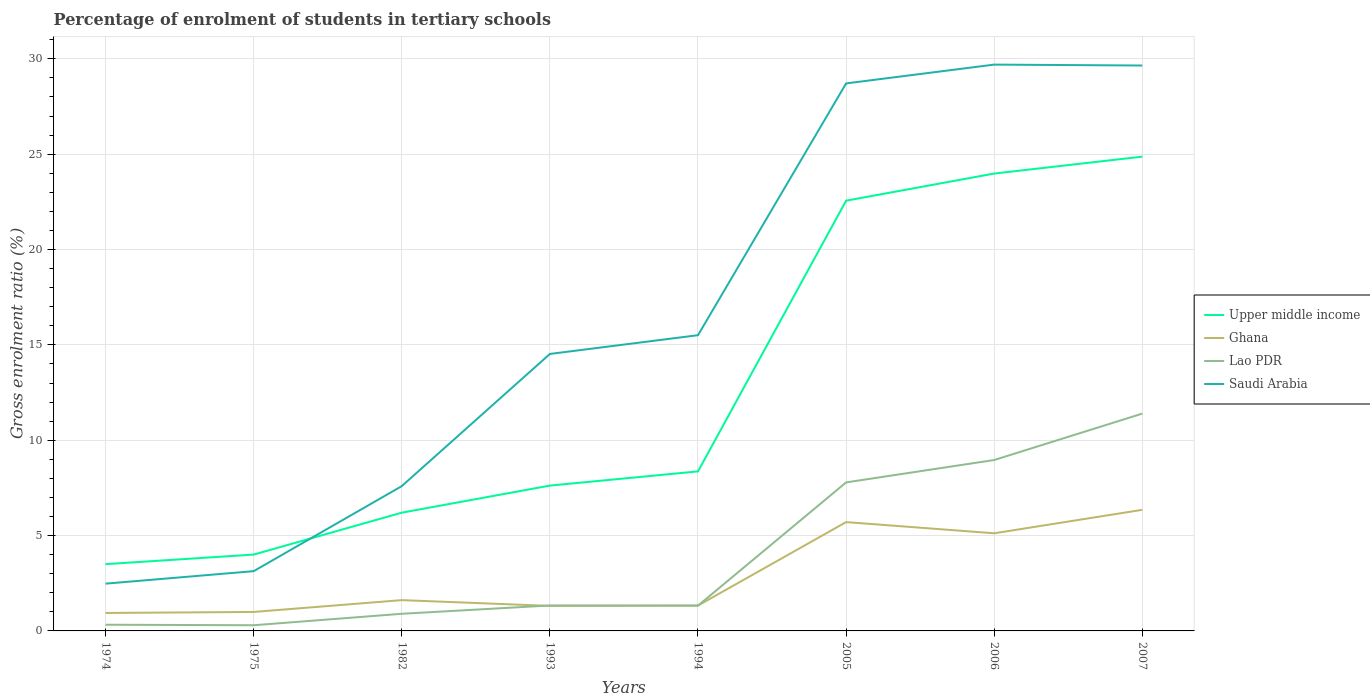How many different coloured lines are there?
Ensure brevity in your answer.  4. Across all years, what is the maximum percentage of students enrolled in tertiary schools in Lao PDR?
Give a very brief answer. 0.3. In which year was the percentage of students enrolled in tertiary schools in Saudi Arabia maximum?
Offer a terse response. 1974. What is the total percentage of students enrolled in tertiary schools in Saudi Arabia in the graph?
Give a very brief answer. -26.56. What is the difference between the highest and the second highest percentage of students enrolled in tertiary schools in Lao PDR?
Your answer should be compact. 11.1. What is the difference between the highest and the lowest percentage of students enrolled in tertiary schools in Ghana?
Your answer should be compact. 3. Does the graph contain any zero values?
Your answer should be compact. No. How are the legend labels stacked?
Offer a terse response. Vertical. What is the title of the graph?
Your answer should be very brief. Percentage of enrolment of students in tertiary schools. What is the label or title of the Y-axis?
Your answer should be compact. Gross enrolment ratio (%). What is the Gross enrolment ratio (%) of Upper middle income in 1974?
Offer a very short reply. 3.5. What is the Gross enrolment ratio (%) of Lao PDR in 1974?
Your answer should be compact. 0.32. What is the Gross enrolment ratio (%) of Saudi Arabia in 1974?
Keep it short and to the point. 2.48. What is the Gross enrolment ratio (%) of Upper middle income in 1975?
Make the answer very short. 4. What is the Gross enrolment ratio (%) of Ghana in 1975?
Offer a very short reply. 1. What is the Gross enrolment ratio (%) of Lao PDR in 1975?
Provide a short and direct response. 0.3. What is the Gross enrolment ratio (%) in Saudi Arabia in 1975?
Your response must be concise. 3.13. What is the Gross enrolment ratio (%) in Upper middle income in 1982?
Offer a terse response. 6.2. What is the Gross enrolment ratio (%) of Ghana in 1982?
Your answer should be compact. 1.62. What is the Gross enrolment ratio (%) in Lao PDR in 1982?
Make the answer very short. 0.9. What is the Gross enrolment ratio (%) of Saudi Arabia in 1982?
Offer a terse response. 7.59. What is the Gross enrolment ratio (%) of Upper middle income in 1993?
Provide a short and direct response. 7.62. What is the Gross enrolment ratio (%) in Ghana in 1993?
Your answer should be very brief. 1.31. What is the Gross enrolment ratio (%) in Lao PDR in 1993?
Make the answer very short. 1.33. What is the Gross enrolment ratio (%) in Saudi Arabia in 1993?
Offer a terse response. 14.52. What is the Gross enrolment ratio (%) in Upper middle income in 1994?
Provide a short and direct response. 8.37. What is the Gross enrolment ratio (%) of Ghana in 1994?
Your answer should be compact. 1.33. What is the Gross enrolment ratio (%) of Lao PDR in 1994?
Your answer should be compact. 1.33. What is the Gross enrolment ratio (%) of Saudi Arabia in 1994?
Provide a short and direct response. 15.51. What is the Gross enrolment ratio (%) in Upper middle income in 2005?
Keep it short and to the point. 22.56. What is the Gross enrolment ratio (%) of Ghana in 2005?
Your response must be concise. 5.71. What is the Gross enrolment ratio (%) in Lao PDR in 2005?
Provide a succinct answer. 7.79. What is the Gross enrolment ratio (%) of Saudi Arabia in 2005?
Provide a short and direct response. 28.71. What is the Gross enrolment ratio (%) of Upper middle income in 2006?
Keep it short and to the point. 23.99. What is the Gross enrolment ratio (%) in Ghana in 2006?
Your answer should be very brief. 5.12. What is the Gross enrolment ratio (%) of Lao PDR in 2006?
Ensure brevity in your answer.  8.96. What is the Gross enrolment ratio (%) of Saudi Arabia in 2006?
Offer a very short reply. 29.7. What is the Gross enrolment ratio (%) in Upper middle income in 2007?
Your answer should be compact. 24.87. What is the Gross enrolment ratio (%) of Ghana in 2007?
Provide a succinct answer. 6.35. What is the Gross enrolment ratio (%) of Lao PDR in 2007?
Keep it short and to the point. 11.4. What is the Gross enrolment ratio (%) of Saudi Arabia in 2007?
Your answer should be very brief. 29.65. Across all years, what is the maximum Gross enrolment ratio (%) of Upper middle income?
Give a very brief answer. 24.87. Across all years, what is the maximum Gross enrolment ratio (%) of Ghana?
Your response must be concise. 6.35. Across all years, what is the maximum Gross enrolment ratio (%) in Lao PDR?
Your answer should be compact. 11.4. Across all years, what is the maximum Gross enrolment ratio (%) of Saudi Arabia?
Your answer should be compact. 29.7. Across all years, what is the minimum Gross enrolment ratio (%) of Upper middle income?
Offer a terse response. 3.5. Across all years, what is the minimum Gross enrolment ratio (%) in Lao PDR?
Give a very brief answer. 0.3. Across all years, what is the minimum Gross enrolment ratio (%) of Saudi Arabia?
Make the answer very short. 2.48. What is the total Gross enrolment ratio (%) in Upper middle income in the graph?
Your response must be concise. 101.12. What is the total Gross enrolment ratio (%) in Ghana in the graph?
Give a very brief answer. 23.37. What is the total Gross enrolment ratio (%) in Lao PDR in the graph?
Your answer should be compact. 32.33. What is the total Gross enrolment ratio (%) in Saudi Arabia in the graph?
Your response must be concise. 131.3. What is the difference between the Gross enrolment ratio (%) of Upper middle income in 1974 and that in 1975?
Give a very brief answer. -0.5. What is the difference between the Gross enrolment ratio (%) of Ghana in 1974 and that in 1975?
Provide a succinct answer. -0.05. What is the difference between the Gross enrolment ratio (%) in Lao PDR in 1974 and that in 1975?
Ensure brevity in your answer.  0.03. What is the difference between the Gross enrolment ratio (%) in Saudi Arabia in 1974 and that in 1975?
Give a very brief answer. -0.66. What is the difference between the Gross enrolment ratio (%) in Upper middle income in 1974 and that in 1982?
Your answer should be very brief. -2.7. What is the difference between the Gross enrolment ratio (%) in Ghana in 1974 and that in 1982?
Provide a succinct answer. -0.67. What is the difference between the Gross enrolment ratio (%) of Lao PDR in 1974 and that in 1982?
Give a very brief answer. -0.57. What is the difference between the Gross enrolment ratio (%) in Saudi Arabia in 1974 and that in 1982?
Provide a short and direct response. -5.12. What is the difference between the Gross enrolment ratio (%) in Upper middle income in 1974 and that in 1993?
Keep it short and to the point. -4.12. What is the difference between the Gross enrolment ratio (%) of Ghana in 1974 and that in 1993?
Your answer should be compact. -0.37. What is the difference between the Gross enrolment ratio (%) in Lao PDR in 1974 and that in 1993?
Offer a very short reply. -1.01. What is the difference between the Gross enrolment ratio (%) of Saudi Arabia in 1974 and that in 1993?
Your answer should be very brief. -12.05. What is the difference between the Gross enrolment ratio (%) in Upper middle income in 1974 and that in 1994?
Provide a succinct answer. -4.87. What is the difference between the Gross enrolment ratio (%) of Ghana in 1974 and that in 1994?
Provide a short and direct response. -0.39. What is the difference between the Gross enrolment ratio (%) of Lao PDR in 1974 and that in 1994?
Provide a short and direct response. -1. What is the difference between the Gross enrolment ratio (%) of Saudi Arabia in 1974 and that in 1994?
Your answer should be very brief. -13.03. What is the difference between the Gross enrolment ratio (%) of Upper middle income in 1974 and that in 2005?
Provide a short and direct response. -19.06. What is the difference between the Gross enrolment ratio (%) of Ghana in 1974 and that in 2005?
Ensure brevity in your answer.  -4.77. What is the difference between the Gross enrolment ratio (%) of Lao PDR in 1974 and that in 2005?
Provide a short and direct response. -7.46. What is the difference between the Gross enrolment ratio (%) in Saudi Arabia in 1974 and that in 2005?
Provide a short and direct response. -26.23. What is the difference between the Gross enrolment ratio (%) in Upper middle income in 1974 and that in 2006?
Offer a very short reply. -20.48. What is the difference between the Gross enrolment ratio (%) of Ghana in 1974 and that in 2006?
Provide a succinct answer. -4.18. What is the difference between the Gross enrolment ratio (%) in Lao PDR in 1974 and that in 2006?
Your response must be concise. -8.64. What is the difference between the Gross enrolment ratio (%) of Saudi Arabia in 1974 and that in 2006?
Your answer should be very brief. -27.22. What is the difference between the Gross enrolment ratio (%) of Upper middle income in 1974 and that in 2007?
Provide a short and direct response. -21.37. What is the difference between the Gross enrolment ratio (%) of Ghana in 1974 and that in 2007?
Your answer should be compact. -5.41. What is the difference between the Gross enrolment ratio (%) of Lao PDR in 1974 and that in 2007?
Provide a short and direct response. -11.07. What is the difference between the Gross enrolment ratio (%) of Saudi Arabia in 1974 and that in 2007?
Ensure brevity in your answer.  -27.17. What is the difference between the Gross enrolment ratio (%) of Upper middle income in 1975 and that in 1982?
Ensure brevity in your answer.  -2.2. What is the difference between the Gross enrolment ratio (%) in Ghana in 1975 and that in 1982?
Your answer should be very brief. -0.62. What is the difference between the Gross enrolment ratio (%) in Lao PDR in 1975 and that in 1982?
Give a very brief answer. -0.6. What is the difference between the Gross enrolment ratio (%) in Saudi Arabia in 1975 and that in 1982?
Offer a terse response. -4.46. What is the difference between the Gross enrolment ratio (%) in Upper middle income in 1975 and that in 1993?
Your answer should be compact. -3.62. What is the difference between the Gross enrolment ratio (%) in Ghana in 1975 and that in 1993?
Provide a succinct answer. -0.32. What is the difference between the Gross enrolment ratio (%) of Lao PDR in 1975 and that in 1993?
Your answer should be very brief. -1.04. What is the difference between the Gross enrolment ratio (%) of Saudi Arabia in 1975 and that in 1993?
Ensure brevity in your answer.  -11.39. What is the difference between the Gross enrolment ratio (%) in Upper middle income in 1975 and that in 1994?
Ensure brevity in your answer.  -4.36. What is the difference between the Gross enrolment ratio (%) of Ghana in 1975 and that in 1994?
Keep it short and to the point. -0.33. What is the difference between the Gross enrolment ratio (%) of Lao PDR in 1975 and that in 1994?
Offer a terse response. -1.03. What is the difference between the Gross enrolment ratio (%) in Saudi Arabia in 1975 and that in 1994?
Your answer should be compact. -12.38. What is the difference between the Gross enrolment ratio (%) in Upper middle income in 1975 and that in 2005?
Make the answer very short. -18.56. What is the difference between the Gross enrolment ratio (%) of Ghana in 1975 and that in 2005?
Offer a very short reply. -4.71. What is the difference between the Gross enrolment ratio (%) of Lao PDR in 1975 and that in 2005?
Keep it short and to the point. -7.49. What is the difference between the Gross enrolment ratio (%) in Saudi Arabia in 1975 and that in 2005?
Your answer should be compact. -25.58. What is the difference between the Gross enrolment ratio (%) of Upper middle income in 1975 and that in 2006?
Provide a succinct answer. -19.98. What is the difference between the Gross enrolment ratio (%) in Ghana in 1975 and that in 2006?
Provide a short and direct response. -4.13. What is the difference between the Gross enrolment ratio (%) of Lao PDR in 1975 and that in 2006?
Make the answer very short. -8.66. What is the difference between the Gross enrolment ratio (%) of Saudi Arabia in 1975 and that in 2006?
Your answer should be very brief. -26.57. What is the difference between the Gross enrolment ratio (%) in Upper middle income in 1975 and that in 2007?
Your response must be concise. -20.87. What is the difference between the Gross enrolment ratio (%) in Ghana in 1975 and that in 2007?
Give a very brief answer. -5.36. What is the difference between the Gross enrolment ratio (%) in Lao PDR in 1975 and that in 2007?
Ensure brevity in your answer.  -11.1. What is the difference between the Gross enrolment ratio (%) of Saudi Arabia in 1975 and that in 2007?
Your answer should be very brief. -26.52. What is the difference between the Gross enrolment ratio (%) of Upper middle income in 1982 and that in 1993?
Offer a terse response. -1.42. What is the difference between the Gross enrolment ratio (%) in Ghana in 1982 and that in 1993?
Provide a succinct answer. 0.3. What is the difference between the Gross enrolment ratio (%) in Lao PDR in 1982 and that in 1993?
Provide a succinct answer. -0.44. What is the difference between the Gross enrolment ratio (%) in Saudi Arabia in 1982 and that in 1993?
Give a very brief answer. -6.93. What is the difference between the Gross enrolment ratio (%) in Upper middle income in 1982 and that in 1994?
Your answer should be very brief. -2.17. What is the difference between the Gross enrolment ratio (%) in Ghana in 1982 and that in 1994?
Provide a short and direct response. 0.29. What is the difference between the Gross enrolment ratio (%) in Lao PDR in 1982 and that in 1994?
Provide a short and direct response. -0.43. What is the difference between the Gross enrolment ratio (%) in Saudi Arabia in 1982 and that in 1994?
Keep it short and to the point. -7.92. What is the difference between the Gross enrolment ratio (%) in Upper middle income in 1982 and that in 2005?
Offer a very short reply. -16.36. What is the difference between the Gross enrolment ratio (%) of Ghana in 1982 and that in 2005?
Provide a short and direct response. -4.09. What is the difference between the Gross enrolment ratio (%) of Lao PDR in 1982 and that in 2005?
Offer a terse response. -6.89. What is the difference between the Gross enrolment ratio (%) in Saudi Arabia in 1982 and that in 2005?
Offer a very short reply. -21.12. What is the difference between the Gross enrolment ratio (%) of Upper middle income in 1982 and that in 2006?
Offer a terse response. -17.78. What is the difference between the Gross enrolment ratio (%) of Ghana in 1982 and that in 2006?
Your answer should be compact. -3.51. What is the difference between the Gross enrolment ratio (%) in Lao PDR in 1982 and that in 2006?
Keep it short and to the point. -8.06. What is the difference between the Gross enrolment ratio (%) in Saudi Arabia in 1982 and that in 2006?
Make the answer very short. -22.1. What is the difference between the Gross enrolment ratio (%) in Upper middle income in 1982 and that in 2007?
Your answer should be compact. -18.67. What is the difference between the Gross enrolment ratio (%) of Ghana in 1982 and that in 2007?
Ensure brevity in your answer.  -4.74. What is the difference between the Gross enrolment ratio (%) of Lao PDR in 1982 and that in 2007?
Your response must be concise. -10.5. What is the difference between the Gross enrolment ratio (%) in Saudi Arabia in 1982 and that in 2007?
Provide a succinct answer. -22.06. What is the difference between the Gross enrolment ratio (%) in Upper middle income in 1993 and that in 1994?
Provide a succinct answer. -0.75. What is the difference between the Gross enrolment ratio (%) in Ghana in 1993 and that in 1994?
Give a very brief answer. -0.02. What is the difference between the Gross enrolment ratio (%) in Lao PDR in 1993 and that in 1994?
Give a very brief answer. 0.01. What is the difference between the Gross enrolment ratio (%) of Saudi Arabia in 1993 and that in 1994?
Make the answer very short. -0.98. What is the difference between the Gross enrolment ratio (%) in Upper middle income in 1993 and that in 2005?
Make the answer very short. -14.94. What is the difference between the Gross enrolment ratio (%) of Ghana in 1993 and that in 2005?
Provide a succinct answer. -4.39. What is the difference between the Gross enrolment ratio (%) in Lao PDR in 1993 and that in 2005?
Give a very brief answer. -6.45. What is the difference between the Gross enrolment ratio (%) of Saudi Arabia in 1993 and that in 2005?
Make the answer very short. -14.19. What is the difference between the Gross enrolment ratio (%) in Upper middle income in 1993 and that in 2006?
Provide a short and direct response. -16.36. What is the difference between the Gross enrolment ratio (%) of Ghana in 1993 and that in 2006?
Offer a terse response. -3.81. What is the difference between the Gross enrolment ratio (%) in Lao PDR in 1993 and that in 2006?
Your response must be concise. -7.63. What is the difference between the Gross enrolment ratio (%) in Saudi Arabia in 1993 and that in 2006?
Offer a very short reply. -15.17. What is the difference between the Gross enrolment ratio (%) of Upper middle income in 1993 and that in 2007?
Offer a terse response. -17.25. What is the difference between the Gross enrolment ratio (%) in Ghana in 1993 and that in 2007?
Your answer should be compact. -5.04. What is the difference between the Gross enrolment ratio (%) of Lao PDR in 1993 and that in 2007?
Make the answer very short. -10.06. What is the difference between the Gross enrolment ratio (%) of Saudi Arabia in 1993 and that in 2007?
Give a very brief answer. -15.13. What is the difference between the Gross enrolment ratio (%) in Upper middle income in 1994 and that in 2005?
Provide a short and direct response. -14.2. What is the difference between the Gross enrolment ratio (%) in Ghana in 1994 and that in 2005?
Provide a short and direct response. -4.38. What is the difference between the Gross enrolment ratio (%) of Lao PDR in 1994 and that in 2005?
Provide a short and direct response. -6.46. What is the difference between the Gross enrolment ratio (%) of Saudi Arabia in 1994 and that in 2005?
Give a very brief answer. -13.2. What is the difference between the Gross enrolment ratio (%) in Upper middle income in 1994 and that in 2006?
Your answer should be very brief. -15.62. What is the difference between the Gross enrolment ratio (%) of Ghana in 1994 and that in 2006?
Make the answer very short. -3.79. What is the difference between the Gross enrolment ratio (%) of Lao PDR in 1994 and that in 2006?
Provide a succinct answer. -7.64. What is the difference between the Gross enrolment ratio (%) of Saudi Arabia in 1994 and that in 2006?
Make the answer very short. -14.19. What is the difference between the Gross enrolment ratio (%) of Upper middle income in 1994 and that in 2007?
Provide a succinct answer. -16.51. What is the difference between the Gross enrolment ratio (%) in Ghana in 1994 and that in 2007?
Offer a very short reply. -5.02. What is the difference between the Gross enrolment ratio (%) in Lao PDR in 1994 and that in 2007?
Provide a short and direct response. -10.07. What is the difference between the Gross enrolment ratio (%) of Saudi Arabia in 1994 and that in 2007?
Ensure brevity in your answer.  -14.14. What is the difference between the Gross enrolment ratio (%) in Upper middle income in 2005 and that in 2006?
Provide a short and direct response. -1.42. What is the difference between the Gross enrolment ratio (%) of Ghana in 2005 and that in 2006?
Your answer should be compact. 0.59. What is the difference between the Gross enrolment ratio (%) in Lao PDR in 2005 and that in 2006?
Ensure brevity in your answer.  -1.17. What is the difference between the Gross enrolment ratio (%) in Saudi Arabia in 2005 and that in 2006?
Keep it short and to the point. -0.99. What is the difference between the Gross enrolment ratio (%) of Upper middle income in 2005 and that in 2007?
Your answer should be very brief. -2.31. What is the difference between the Gross enrolment ratio (%) in Ghana in 2005 and that in 2007?
Your response must be concise. -0.64. What is the difference between the Gross enrolment ratio (%) in Lao PDR in 2005 and that in 2007?
Keep it short and to the point. -3.61. What is the difference between the Gross enrolment ratio (%) in Saudi Arabia in 2005 and that in 2007?
Keep it short and to the point. -0.94. What is the difference between the Gross enrolment ratio (%) in Upper middle income in 2006 and that in 2007?
Your response must be concise. -0.89. What is the difference between the Gross enrolment ratio (%) of Ghana in 2006 and that in 2007?
Give a very brief answer. -1.23. What is the difference between the Gross enrolment ratio (%) in Lao PDR in 2006 and that in 2007?
Provide a succinct answer. -2.43. What is the difference between the Gross enrolment ratio (%) in Saudi Arabia in 2006 and that in 2007?
Ensure brevity in your answer.  0.05. What is the difference between the Gross enrolment ratio (%) of Upper middle income in 1974 and the Gross enrolment ratio (%) of Ghana in 1975?
Ensure brevity in your answer.  2.51. What is the difference between the Gross enrolment ratio (%) of Upper middle income in 1974 and the Gross enrolment ratio (%) of Lao PDR in 1975?
Keep it short and to the point. 3.2. What is the difference between the Gross enrolment ratio (%) of Upper middle income in 1974 and the Gross enrolment ratio (%) of Saudi Arabia in 1975?
Your answer should be compact. 0.37. What is the difference between the Gross enrolment ratio (%) in Ghana in 1974 and the Gross enrolment ratio (%) in Lao PDR in 1975?
Your answer should be compact. 0.64. What is the difference between the Gross enrolment ratio (%) of Ghana in 1974 and the Gross enrolment ratio (%) of Saudi Arabia in 1975?
Offer a very short reply. -2.19. What is the difference between the Gross enrolment ratio (%) in Lao PDR in 1974 and the Gross enrolment ratio (%) in Saudi Arabia in 1975?
Give a very brief answer. -2.81. What is the difference between the Gross enrolment ratio (%) of Upper middle income in 1974 and the Gross enrolment ratio (%) of Ghana in 1982?
Offer a terse response. 1.89. What is the difference between the Gross enrolment ratio (%) in Upper middle income in 1974 and the Gross enrolment ratio (%) in Lao PDR in 1982?
Your response must be concise. 2.6. What is the difference between the Gross enrolment ratio (%) of Upper middle income in 1974 and the Gross enrolment ratio (%) of Saudi Arabia in 1982?
Make the answer very short. -4.09. What is the difference between the Gross enrolment ratio (%) of Ghana in 1974 and the Gross enrolment ratio (%) of Lao PDR in 1982?
Provide a succinct answer. 0.04. What is the difference between the Gross enrolment ratio (%) of Ghana in 1974 and the Gross enrolment ratio (%) of Saudi Arabia in 1982?
Your answer should be compact. -6.65. What is the difference between the Gross enrolment ratio (%) in Lao PDR in 1974 and the Gross enrolment ratio (%) in Saudi Arabia in 1982?
Offer a terse response. -7.27. What is the difference between the Gross enrolment ratio (%) of Upper middle income in 1974 and the Gross enrolment ratio (%) of Ghana in 1993?
Offer a terse response. 2.19. What is the difference between the Gross enrolment ratio (%) in Upper middle income in 1974 and the Gross enrolment ratio (%) in Lao PDR in 1993?
Offer a terse response. 2.17. What is the difference between the Gross enrolment ratio (%) of Upper middle income in 1974 and the Gross enrolment ratio (%) of Saudi Arabia in 1993?
Provide a short and direct response. -11.02. What is the difference between the Gross enrolment ratio (%) of Ghana in 1974 and the Gross enrolment ratio (%) of Lao PDR in 1993?
Offer a very short reply. -0.39. What is the difference between the Gross enrolment ratio (%) of Ghana in 1974 and the Gross enrolment ratio (%) of Saudi Arabia in 1993?
Keep it short and to the point. -13.58. What is the difference between the Gross enrolment ratio (%) in Lao PDR in 1974 and the Gross enrolment ratio (%) in Saudi Arabia in 1993?
Ensure brevity in your answer.  -14.2. What is the difference between the Gross enrolment ratio (%) in Upper middle income in 1974 and the Gross enrolment ratio (%) in Ghana in 1994?
Your answer should be very brief. 2.17. What is the difference between the Gross enrolment ratio (%) in Upper middle income in 1974 and the Gross enrolment ratio (%) in Lao PDR in 1994?
Offer a terse response. 2.17. What is the difference between the Gross enrolment ratio (%) in Upper middle income in 1974 and the Gross enrolment ratio (%) in Saudi Arabia in 1994?
Offer a very short reply. -12.01. What is the difference between the Gross enrolment ratio (%) in Ghana in 1974 and the Gross enrolment ratio (%) in Lao PDR in 1994?
Provide a succinct answer. -0.39. What is the difference between the Gross enrolment ratio (%) of Ghana in 1974 and the Gross enrolment ratio (%) of Saudi Arabia in 1994?
Ensure brevity in your answer.  -14.57. What is the difference between the Gross enrolment ratio (%) in Lao PDR in 1974 and the Gross enrolment ratio (%) in Saudi Arabia in 1994?
Your response must be concise. -15.18. What is the difference between the Gross enrolment ratio (%) of Upper middle income in 1974 and the Gross enrolment ratio (%) of Ghana in 2005?
Provide a short and direct response. -2.21. What is the difference between the Gross enrolment ratio (%) in Upper middle income in 1974 and the Gross enrolment ratio (%) in Lao PDR in 2005?
Ensure brevity in your answer.  -4.29. What is the difference between the Gross enrolment ratio (%) in Upper middle income in 1974 and the Gross enrolment ratio (%) in Saudi Arabia in 2005?
Offer a very short reply. -25.21. What is the difference between the Gross enrolment ratio (%) in Ghana in 1974 and the Gross enrolment ratio (%) in Lao PDR in 2005?
Ensure brevity in your answer.  -6.85. What is the difference between the Gross enrolment ratio (%) in Ghana in 1974 and the Gross enrolment ratio (%) in Saudi Arabia in 2005?
Ensure brevity in your answer.  -27.77. What is the difference between the Gross enrolment ratio (%) of Lao PDR in 1974 and the Gross enrolment ratio (%) of Saudi Arabia in 2005?
Keep it short and to the point. -28.39. What is the difference between the Gross enrolment ratio (%) in Upper middle income in 1974 and the Gross enrolment ratio (%) in Ghana in 2006?
Ensure brevity in your answer.  -1.62. What is the difference between the Gross enrolment ratio (%) in Upper middle income in 1974 and the Gross enrolment ratio (%) in Lao PDR in 2006?
Make the answer very short. -5.46. What is the difference between the Gross enrolment ratio (%) of Upper middle income in 1974 and the Gross enrolment ratio (%) of Saudi Arabia in 2006?
Your answer should be compact. -26.2. What is the difference between the Gross enrolment ratio (%) of Ghana in 1974 and the Gross enrolment ratio (%) of Lao PDR in 2006?
Your response must be concise. -8.02. What is the difference between the Gross enrolment ratio (%) in Ghana in 1974 and the Gross enrolment ratio (%) in Saudi Arabia in 2006?
Your response must be concise. -28.76. What is the difference between the Gross enrolment ratio (%) of Lao PDR in 1974 and the Gross enrolment ratio (%) of Saudi Arabia in 2006?
Your answer should be compact. -29.37. What is the difference between the Gross enrolment ratio (%) in Upper middle income in 1974 and the Gross enrolment ratio (%) in Ghana in 2007?
Give a very brief answer. -2.85. What is the difference between the Gross enrolment ratio (%) in Upper middle income in 1974 and the Gross enrolment ratio (%) in Lao PDR in 2007?
Your answer should be compact. -7.9. What is the difference between the Gross enrolment ratio (%) in Upper middle income in 1974 and the Gross enrolment ratio (%) in Saudi Arabia in 2007?
Make the answer very short. -26.15. What is the difference between the Gross enrolment ratio (%) in Ghana in 1974 and the Gross enrolment ratio (%) in Lao PDR in 2007?
Offer a terse response. -10.46. What is the difference between the Gross enrolment ratio (%) of Ghana in 1974 and the Gross enrolment ratio (%) of Saudi Arabia in 2007?
Provide a succinct answer. -28.71. What is the difference between the Gross enrolment ratio (%) of Lao PDR in 1974 and the Gross enrolment ratio (%) of Saudi Arabia in 2007?
Offer a very short reply. -29.33. What is the difference between the Gross enrolment ratio (%) of Upper middle income in 1975 and the Gross enrolment ratio (%) of Ghana in 1982?
Give a very brief answer. 2.39. What is the difference between the Gross enrolment ratio (%) of Upper middle income in 1975 and the Gross enrolment ratio (%) of Lao PDR in 1982?
Provide a succinct answer. 3.1. What is the difference between the Gross enrolment ratio (%) of Upper middle income in 1975 and the Gross enrolment ratio (%) of Saudi Arabia in 1982?
Keep it short and to the point. -3.59. What is the difference between the Gross enrolment ratio (%) in Ghana in 1975 and the Gross enrolment ratio (%) in Lao PDR in 1982?
Your answer should be compact. 0.1. What is the difference between the Gross enrolment ratio (%) of Ghana in 1975 and the Gross enrolment ratio (%) of Saudi Arabia in 1982?
Your answer should be compact. -6.6. What is the difference between the Gross enrolment ratio (%) in Lao PDR in 1975 and the Gross enrolment ratio (%) in Saudi Arabia in 1982?
Your answer should be very brief. -7.3. What is the difference between the Gross enrolment ratio (%) in Upper middle income in 1975 and the Gross enrolment ratio (%) in Ghana in 1993?
Provide a succinct answer. 2.69. What is the difference between the Gross enrolment ratio (%) of Upper middle income in 1975 and the Gross enrolment ratio (%) of Lao PDR in 1993?
Provide a short and direct response. 2.67. What is the difference between the Gross enrolment ratio (%) of Upper middle income in 1975 and the Gross enrolment ratio (%) of Saudi Arabia in 1993?
Your answer should be compact. -10.52. What is the difference between the Gross enrolment ratio (%) in Ghana in 1975 and the Gross enrolment ratio (%) in Lao PDR in 1993?
Offer a very short reply. -0.34. What is the difference between the Gross enrolment ratio (%) in Ghana in 1975 and the Gross enrolment ratio (%) in Saudi Arabia in 1993?
Give a very brief answer. -13.53. What is the difference between the Gross enrolment ratio (%) in Lao PDR in 1975 and the Gross enrolment ratio (%) in Saudi Arabia in 1993?
Your answer should be compact. -14.23. What is the difference between the Gross enrolment ratio (%) in Upper middle income in 1975 and the Gross enrolment ratio (%) in Ghana in 1994?
Your response must be concise. 2.67. What is the difference between the Gross enrolment ratio (%) of Upper middle income in 1975 and the Gross enrolment ratio (%) of Lao PDR in 1994?
Your answer should be very brief. 2.68. What is the difference between the Gross enrolment ratio (%) of Upper middle income in 1975 and the Gross enrolment ratio (%) of Saudi Arabia in 1994?
Offer a terse response. -11.51. What is the difference between the Gross enrolment ratio (%) of Ghana in 1975 and the Gross enrolment ratio (%) of Lao PDR in 1994?
Provide a short and direct response. -0.33. What is the difference between the Gross enrolment ratio (%) in Ghana in 1975 and the Gross enrolment ratio (%) in Saudi Arabia in 1994?
Provide a succinct answer. -14.51. What is the difference between the Gross enrolment ratio (%) in Lao PDR in 1975 and the Gross enrolment ratio (%) in Saudi Arabia in 1994?
Your response must be concise. -15.21. What is the difference between the Gross enrolment ratio (%) of Upper middle income in 1975 and the Gross enrolment ratio (%) of Ghana in 2005?
Your answer should be compact. -1.7. What is the difference between the Gross enrolment ratio (%) in Upper middle income in 1975 and the Gross enrolment ratio (%) in Lao PDR in 2005?
Keep it short and to the point. -3.79. What is the difference between the Gross enrolment ratio (%) in Upper middle income in 1975 and the Gross enrolment ratio (%) in Saudi Arabia in 2005?
Offer a terse response. -24.71. What is the difference between the Gross enrolment ratio (%) in Ghana in 1975 and the Gross enrolment ratio (%) in Lao PDR in 2005?
Your response must be concise. -6.79. What is the difference between the Gross enrolment ratio (%) in Ghana in 1975 and the Gross enrolment ratio (%) in Saudi Arabia in 2005?
Keep it short and to the point. -27.72. What is the difference between the Gross enrolment ratio (%) in Lao PDR in 1975 and the Gross enrolment ratio (%) in Saudi Arabia in 2005?
Offer a very short reply. -28.41. What is the difference between the Gross enrolment ratio (%) in Upper middle income in 1975 and the Gross enrolment ratio (%) in Ghana in 2006?
Provide a succinct answer. -1.12. What is the difference between the Gross enrolment ratio (%) in Upper middle income in 1975 and the Gross enrolment ratio (%) in Lao PDR in 2006?
Give a very brief answer. -4.96. What is the difference between the Gross enrolment ratio (%) of Upper middle income in 1975 and the Gross enrolment ratio (%) of Saudi Arabia in 2006?
Ensure brevity in your answer.  -25.7. What is the difference between the Gross enrolment ratio (%) of Ghana in 1975 and the Gross enrolment ratio (%) of Lao PDR in 2006?
Offer a terse response. -7.97. What is the difference between the Gross enrolment ratio (%) in Ghana in 1975 and the Gross enrolment ratio (%) in Saudi Arabia in 2006?
Provide a succinct answer. -28.7. What is the difference between the Gross enrolment ratio (%) of Lao PDR in 1975 and the Gross enrolment ratio (%) of Saudi Arabia in 2006?
Your answer should be compact. -29.4. What is the difference between the Gross enrolment ratio (%) of Upper middle income in 1975 and the Gross enrolment ratio (%) of Ghana in 2007?
Your answer should be very brief. -2.35. What is the difference between the Gross enrolment ratio (%) of Upper middle income in 1975 and the Gross enrolment ratio (%) of Lao PDR in 2007?
Provide a short and direct response. -7.39. What is the difference between the Gross enrolment ratio (%) of Upper middle income in 1975 and the Gross enrolment ratio (%) of Saudi Arabia in 2007?
Give a very brief answer. -25.65. What is the difference between the Gross enrolment ratio (%) of Ghana in 1975 and the Gross enrolment ratio (%) of Lao PDR in 2007?
Provide a succinct answer. -10.4. What is the difference between the Gross enrolment ratio (%) of Ghana in 1975 and the Gross enrolment ratio (%) of Saudi Arabia in 2007?
Offer a very short reply. -28.66. What is the difference between the Gross enrolment ratio (%) in Lao PDR in 1975 and the Gross enrolment ratio (%) in Saudi Arabia in 2007?
Ensure brevity in your answer.  -29.35. What is the difference between the Gross enrolment ratio (%) in Upper middle income in 1982 and the Gross enrolment ratio (%) in Ghana in 1993?
Ensure brevity in your answer.  4.89. What is the difference between the Gross enrolment ratio (%) in Upper middle income in 1982 and the Gross enrolment ratio (%) in Lao PDR in 1993?
Your answer should be very brief. 4.87. What is the difference between the Gross enrolment ratio (%) in Upper middle income in 1982 and the Gross enrolment ratio (%) in Saudi Arabia in 1993?
Offer a terse response. -8.32. What is the difference between the Gross enrolment ratio (%) of Ghana in 1982 and the Gross enrolment ratio (%) of Lao PDR in 1993?
Your response must be concise. 0.28. What is the difference between the Gross enrolment ratio (%) in Ghana in 1982 and the Gross enrolment ratio (%) in Saudi Arabia in 1993?
Provide a succinct answer. -12.91. What is the difference between the Gross enrolment ratio (%) in Lao PDR in 1982 and the Gross enrolment ratio (%) in Saudi Arabia in 1993?
Provide a short and direct response. -13.63. What is the difference between the Gross enrolment ratio (%) of Upper middle income in 1982 and the Gross enrolment ratio (%) of Ghana in 1994?
Offer a very short reply. 4.87. What is the difference between the Gross enrolment ratio (%) of Upper middle income in 1982 and the Gross enrolment ratio (%) of Lao PDR in 1994?
Offer a very short reply. 4.88. What is the difference between the Gross enrolment ratio (%) of Upper middle income in 1982 and the Gross enrolment ratio (%) of Saudi Arabia in 1994?
Your response must be concise. -9.31. What is the difference between the Gross enrolment ratio (%) of Ghana in 1982 and the Gross enrolment ratio (%) of Lao PDR in 1994?
Give a very brief answer. 0.29. What is the difference between the Gross enrolment ratio (%) in Ghana in 1982 and the Gross enrolment ratio (%) in Saudi Arabia in 1994?
Your answer should be compact. -13.89. What is the difference between the Gross enrolment ratio (%) of Lao PDR in 1982 and the Gross enrolment ratio (%) of Saudi Arabia in 1994?
Make the answer very short. -14.61. What is the difference between the Gross enrolment ratio (%) of Upper middle income in 1982 and the Gross enrolment ratio (%) of Ghana in 2005?
Keep it short and to the point. 0.49. What is the difference between the Gross enrolment ratio (%) of Upper middle income in 1982 and the Gross enrolment ratio (%) of Lao PDR in 2005?
Give a very brief answer. -1.59. What is the difference between the Gross enrolment ratio (%) of Upper middle income in 1982 and the Gross enrolment ratio (%) of Saudi Arabia in 2005?
Offer a terse response. -22.51. What is the difference between the Gross enrolment ratio (%) in Ghana in 1982 and the Gross enrolment ratio (%) in Lao PDR in 2005?
Your answer should be compact. -6.17. What is the difference between the Gross enrolment ratio (%) of Ghana in 1982 and the Gross enrolment ratio (%) of Saudi Arabia in 2005?
Your answer should be very brief. -27.1. What is the difference between the Gross enrolment ratio (%) of Lao PDR in 1982 and the Gross enrolment ratio (%) of Saudi Arabia in 2005?
Keep it short and to the point. -27.81. What is the difference between the Gross enrolment ratio (%) of Upper middle income in 1982 and the Gross enrolment ratio (%) of Ghana in 2006?
Your answer should be compact. 1.08. What is the difference between the Gross enrolment ratio (%) of Upper middle income in 1982 and the Gross enrolment ratio (%) of Lao PDR in 2006?
Give a very brief answer. -2.76. What is the difference between the Gross enrolment ratio (%) in Upper middle income in 1982 and the Gross enrolment ratio (%) in Saudi Arabia in 2006?
Provide a short and direct response. -23.5. What is the difference between the Gross enrolment ratio (%) in Ghana in 1982 and the Gross enrolment ratio (%) in Lao PDR in 2006?
Ensure brevity in your answer.  -7.35. What is the difference between the Gross enrolment ratio (%) in Ghana in 1982 and the Gross enrolment ratio (%) in Saudi Arabia in 2006?
Offer a very short reply. -28.08. What is the difference between the Gross enrolment ratio (%) in Lao PDR in 1982 and the Gross enrolment ratio (%) in Saudi Arabia in 2006?
Your answer should be very brief. -28.8. What is the difference between the Gross enrolment ratio (%) in Upper middle income in 1982 and the Gross enrolment ratio (%) in Ghana in 2007?
Your answer should be compact. -0.15. What is the difference between the Gross enrolment ratio (%) of Upper middle income in 1982 and the Gross enrolment ratio (%) of Lao PDR in 2007?
Your response must be concise. -5.2. What is the difference between the Gross enrolment ratio (%) of Upper middle income in 1982 and the Gross enrolment ratio (%) of Saudi Arabia in 2007?
Your answer should be very brief. -23.45. What is the difference between the Gross enrolment ratio (%) of Ghana in 1982 and the Gross enrolment ratio (%) of Lao PDR in 2007?
Offer a very short reply. -9.78. What is the difference between the Gross enrolment ratio (%) in Ghana in 1982 and the Gross enrolment ratio (%) in Saudi Arabia in 2007?
Offer a terse response. -28.04. What is the difference between the Gross enrolment ratio (%) of Lao PDR in 1982 and the Gross enrolment ratio (%) of Saudi Arabia in 2007?
Provide a short and direct response. -28.75. What is the difference between the Gross enrolment ratio (%) of Upper middle income in 1993 and the Gross enrolment ratio (%) of Ghana in 1994?
Keep it short and to the point. 6.29. What is the difference between the Gross enrolment ratio (%) of Upper middle income in 1993 and the Gross enrolment ratio (%) of Lao PDR in 1994?
Make the answer very short. 6.3. What is the difference between the Gross enrolment ratio (%) in Upper middle income in 1993 and the Gross enrolment ratio (%) in Saudi Arabia in 1994?
Offer a very short reply. -7.89. What is the difference between the Gross enrolment ratio (%) of Ghana in 1993 and the Gross enrolment ratio (%) of Lao PDR in 1994?
Make the answer very short. -0.01. What is the difference between the Gross enrolment ratio (%) of Ghana in 1993 and the Gross enrolment ratio (%) of Saudi Arabia in 1994?
Your answer should be very brief. -14.2. What is the difference between the Gross enrolment ratio (%) of Lao PDR in 1993 and the Gross enrolment ratio (%) of Saudi Arabia in 1994?
Offer a very short reply. -14.17. What is the difference between the Gross enrolment ratio (%) in Upper middle income in 1993 and the Gross enrolment ratio (%) in Ghana in 2005?
Make the answer very short. 1.91. What is the difference between the Gross enrolment ratio (%) of Upper middle income in 1993 and the Gross enrolment ratio (%) of Lao PDR in 2005?
Your response must be concise. -0.17. What is the difference between the Gross enrolment ratio (%) in Upper middle income in 1993 and the Gross enrolment ratio (%) in Saudi Arabia in 2005?
Make the answer very short. -21.09. What is the difference between the Gross enrolment ratio (%) of Ghana in 1993 and the Gross enrolment ratio (%) of Lao PDR in 2005?
Your response must be concise. -6.48. What is the difference between the Gross enrolment ratio (%) of Ghana in 1993 and the Gross enrolment ratio (%) of Saudi Arabia in 2005?
Offer a very short reply. -27.4. What is the difference between the Gross enrolment ratio (%) of Lao PDR in 1993 and the Gross enrolment ratio (%) of Saudi Arabia in 2005?
Offer a very short reply. -27.38. What is the difference between the Gross enrolment ratio (%) in Upper middle income in 1993 and the Gross enrolment ratio (%) in Ghana in 2006?
Offer a terse response. 2.5. What is the difference between the Gross enrolment ratio (%) in Upper middle income in 1993 and the Gross enrolment ratio (%) in Lao PDR in 2006?
Your answer should be compact. -1.34. What is the difference between the Gross enrolment ratio (%) of Upper middle income in 1993 and the Gross enrolment ratio (%) of Saudi Arabia in 2006?
Provide a short and direct response. -22.08. What is the difference between the Gross enrolment ratio (%) in Ghana in 1993 and the Gross enrolment ratio (%) in Lao PDR in 2006?
Make the answer very short. -7.65. What is the difference between the Gross enrolment ratio (%) in Ghana in 1993 and the Gross enrolment ratio (%) in Saudi Arabia in 2006?
Offer a very short reply. -28.39. What is the difference between the Gross enrolment ratio (%) of Lao PDR in 1993 and the Gross enrolment ratio (%) of Saudi Arabia in 2006?
Offer a very short reply. -28.36. What is the difference between the Gross enrolment ratio (%) in Upper middle income in 1993 and the Gross enrolment ratio (%) in Ghana in 2007?
Your answer should be very brief. 1.27. What is the difference between the Gross enrolment ratio (%) in Upper middle income in 1993 and the Gross enrolment ratio (%) in Lao PDR in 2007?
Keep it short and to the point. -3.78. What is the difference between the Gross enrolment ratio (%) in Upper middle income in 1993 and the Gross enrolment ratio (%) in Saudi Arabia in 2007?
Offer a very short reply. -22.03. What is the difference between the Gross enrolment ratio (%) in Ghana in 1993 and the Gross enrolment ratio (%) in Lao PDR in 2007?
Offer a very short reply. -10.08. What is the difference between the Gross enrolment ratio (%) of Ghana in 1993 and the Gross enrolment ratio (%) of Saudi Arabia in 2007?
Make the answer very short. -28.34. What is the difference between the Gross enrolment ratio (%) of Lao PDR in 1993 and the Gross enrolment ratio (%) of Saudi Arabia in 2007?
Your response must be concise. -28.32. What is the difference between the Gross enrolment ratio (%) of Upper middle income in 1994 and the Gross enrolment ratio (%) of Ghana in 2005?
Provide a succinct answer. 2.66. What is the difference between the Gross enrolment ratio (%) of Upper middle income in 1994 and the Gross enrolment ratio (%) of Lao PDR in 2005?
Give a very brief answer. 0.58. What is the difference between the Gross enrolment ratio (%) of Upper middle income in 1994 and the Gross enrolment ratio (%) of Saudi Arabia in 2005?
Provide a short and direct response. -20.35. What is the difference between the Gross enrolment ratio (%) in Ghana in 1994 and the Gross enrolment ratio (%) in Lao PDR in 2005?
Your answer should be compact. -6.46. What is the difference between the Gross enrolment ratio (%) of Ghana in 1994 and the Gross enrolment ratio (%) of Saudi Arabia in 2005?
Keep it short and to the point. -27.38. What is the difference between the Gross enrolment ratio (%) in Lao PDR in 1994 and the Gross enrolment ratio (%) in Saudi Arabia in 2005?
Make the answer very short. -27.39. What is the difference between the Gross enrolment ratio (%) of Upper middle income in 1994 and the Gross enrolment ratio (%) of Ghana in 2006?
Provide a short and direct response. 3.25. What is the difference between the Gross enrolment ratio (%) in Upper middle income in 1994 and the Gross enrolment ratio (%) in Lao PDR in 2006?
Give a very brief answer. -0.6. What is the difference between the Gross enrolment ratio (%) of Upper middle income in 1994 and the Gross enrolment ratio (%) of Saudi Arabia in 2006?
Give a very brief answer. -21.33. What is the difference between the Gross enrolment ratio (%) of Ghana in 1994 and the Gross enrolment ratio (%) of Lao PDR in 2006?
Provide a short and direct response. -7.63. What is the difference between the Gross enrolment ratio (%) of Ghana in 1994 and the Gross enrolment ratio (%) of Saudi Arabia in 2006?
Your response must be concise. -28.37. What is the difference between the Gross enrolment ratio (%) in Lao PDR in 1994 and the Gross enrolment ratio (%) in Saudi Arabia in 2006?
Your response must be concise. -28.37. What is the difference between the Gross enrolment ratio (%) of Upper middle income in 1994 and the Gross enrolment ratio (%) of Ghana in 2007?
Your answer should be compact. 2.02. What is the difference between the Gross enrolment ratio (%) of Upper middle income in 1994 and the Gross enrolment ratio (%) of Lao PDR in 2007?
Make the answer very short. -3.03. What is the difference between the Gross enrolment ratio (%) in Upper middle income in 1994 and the Gross enrolment ratio (%) in Saudi Arabia in 2007?
Give a very brief answer. -21.28. What is the difference between the Gross enrolment ratio (%) in Ghana in 1994 and the Gross enrolment ratio (%) in Lao PDR in 2007?
Ensure brevity in your answer.  -10.07. What is the difference between the Gross enrolment ratio (%) in Ghana in 1994 and the Gross enrolment ratio (%) in Saudi Arabia in 2007?
Offer a terse response. -28.32. What is the difference between the Gross enrolment ratio (%) in Lao PDR in 1994 and the Gross enrolment ratio (%) in Saudi Arabia in 2007?
Keep it short and to the point. -28.32. What is the difference between the Gross enrolment ratio (%) of Upper middle income in 2005 and the Gross enrolment ratio (%) of Ghana in 2006?
Provide a succinct answer. 17.44. What is the difference between the Gross enrolment ratio (%) of Upper middle income in 2005 and the Gross enrolment ratio (%) of Lao PDR in 2006?
Provide a succinct answer. 13.6. What is the difference between the Gross enrolment ratio (%) in Upper middle income in 2005 and the Gross enrolment ratio (%) in Saudi Arabia in 2006?
Ensure brevity in your answer.  -7.14. What is the difference between the Gross enrolment ratio (%) in Ghana in 2005 and the Gross enrolment ratio (%) in Lao PDR in 2006?
Your response must be concise. -3.26. What is the difference between the Gross enrolment ratio (%) in Ghana in 2005 and the Gross enrolment ratio (%) in Saudi Arabia in 2006?
Offer a terse response. -23.99. What is the difference between the Gross enrolment ratio (%) of Lao PDR in 2005 and the Gross enrolment ratio (%) of Saudi Arabia in 2006?
Your answer should be very brief. -21.91. What is the difference between the Gross enrolment ratio (%) in Upper middle income in 2005 and the Gross enrolment ratio (%) in Ghana in 2007?
Offer a very short reply. 16.21. What is the difference between the Gross enrolment ratio (%) in Upper middle income in 2005 and the Gross enrolment ratio (%) in Lao PDR in 2007?
Make the answer very short. 11.17. What is the difference between the Gross enrolment ratio (%) of Upper middle income in 2005 and the Gross enrolment ratio (%) of Saudi Arabia in 2007?
Provide a short and direct response. -7.09. What is the difference between the Gross enrolment ratio (%) in Ghana in 2005 and the Gross enrolment ratio (%) in Lao PDR in 2007?
Give a very brief answer. -5.69. What is the difference between the Gross enrolment ratio (%) in Ghana in 2005 and the Gross enrolment ratio (%) in Saudi Arabia in 2007?
Provide a succinct answer. -23.94. What is the difference between the Gross enrolment ratio (%) of Lao PDR in 2005 and the Gross enrolment ratio (%) of Saudi Arabia in 2007?
Ensure brevity in your answer.  -21.86. What is the difference between the Gross enrolment ratio (%) of Upper middle income in 2006 and the Gross enrolment ratio (%) of Ghana in 2007?
Keep it short and to the point. 17.63. What is the difference between the Gross enrolment ratio (%) in Upper middle income in 2006 and the Gross enrolment ratio (%) in Lao PDR in 2007?
Your answer should be very brief. 12.59. What is the difference between the Gross enrolment ratio (%) of Upper middle income in 2006 and the Gross enrolment ratio (%) of Saudi Arabia in 2007?
Provide a succinct answer. -5.67. What is the difference between the Gross enrolment ratio (%) of Ghana in 2006 and the Gross enrolment ratio (%) of Lao PDR in 2007?
Provide a short and direct response. -6.28. What is the difference between the Gross enrolment ratio (%) in Ghana in 2006 and the Gross enrolment ratio (%) in Saudi Arabia in 2007?
Keep it short and to the point. -24.53. What is the difference between the Gross enrolment ratio (%) in Lao PDR in 2006 and the Gross enrolment ratio (%) in Saudi Arabia in 2007?
Ensure brevity in your answer.  -20.69. What is the average Gross enrolment ratio (%) in Upper middle income per year?
Your answer should be very brief. 12.64. What is the average Gross enrolment ratio (%) in Ghana per year?
Your answer should be very brief. 2.92. What is the average Gross enrolment ratio (%) in Lao PDR per year?
Offer a terse response. 4.04. What is the average Gross enrolment ratio (%) of Saudi Arabia per year?
Offer a very short reply. 16.41. In the year 1974, what is the difference between the Gross enrolment ratio (%) of Upper middle income and Gross enrolment ratio (%) of Ghana?
Ensure brevity in your answer.  2.56. In the year 1974, what is the difference between the Gross enrolment ratio (%) in Upper middle income and Gross enrolment ratio (%) in Lao PDR?
Your answer should be very brief. 3.18. In the year 1974, what is the difference between the Gross enrolment ratio (%) of Upper middle income and Gross enrolment ratio (%) of Saudi Arabia?
Your response must be concise. 1.02. In the year 1974, what is the difference between the Gross enrolment ratio (%) in Ghana and Gross enrolment ratio (%) in Lao PDR?
Offer a very short reply. 0.62. In the year 1974, what is the difference between the Gross enrolment ratio (%) in Ghana and Gross enrolment ratio (%) in Saudi Arabia?
Your response must be concise. -1.54. In the year 1974, what is the difference between the Gross enrolment ratio (%) of Lao PDR and Gross enrolment ratio (%) of Saudi Arabia?
Give a very brief answer. -2.15. In the year 1975, what is the difference between the Gross enrolment ratio (%) in Upper middle income and Gross enrolment ratio (%) in Ghana?
Offer a terse response. 3.01. In the year 1975, what is the difference between the Gross enrolment ratio (%) in Upper middle income and Gross enrolment ratio (%) in Lao PDR?
Keep it short and to the point. 3.7. In the year 1975, what is the difference between the Gross enrolment ratio (%) of Upper middle income and Gross enrolment ratio (%) of Saudi Arabia?
Keep it short and to the point. 0.87. In the year 1975, what is the difference between the Gross enrolment ratio (%) of Ghana and Gross enrolment ratio (%) of Lao PDR?
Your response must be concise. 0.7. In the year 1975, what is the difference between the Gross enrolment ratio (%) in Ghana and Gross enrolment ratio (%) in Saudi Arabia?
Provide a short and direct response. -2.14. In the year 1975, what is the difference between the Gross enrolment ratio (%) in Lao PDR and Gross enrolment ratio (%) in Saudi Arabia?
Provide a succinct answer. -2.84. In the year 1982, what is the difference between the Gross enrolment ratio (%) in Upper middle income and Gross enrolment ratio (%) in Ghana?
Your answer should be compact. 4.59. In the year 1982, what is the difference between the Gross enrolment ratio (%) in Upper middle income and Gross enrolment ratio (%) in Lao PDR?
Provide a succinct answer. 5.3. In the year 1982, what is the difference between the Gross enrolment ratio (%) of Upper middle income and Gross enrolment ratio (%) of Saudi Arabia?
Offer a very short reply. -1.39. In the year 1982, what is the difference between the Gross enrolment ratio (%) in Ghana and Gross enrolment ratio (%) in Lao PDR?
Your answer should be compact. 0.72. In the year 1982, what is the difference between the Gross enrolment ratio (%) in Ghana and Gross enrolment ratio (%) in Saudi Arabia?
Offer a terse response. -5.98. In the year 1982, what is the difference between the Gross enrolment ratio (%) of Lao PDR and Gross enrolment ratio (%) of Saudi Arabia?
Your answer should be very brief. -6.7. In the year 1993, what is the difference between the Gross enrolment ratio (%) in Upper middle income and Gross enrolment ratio (%) in Ghana?
Make the answer very short. 6.31. In the year 1993, what is the difference between the Gross enrolment ratio (%) in Upper middle income and Gross enrolment ratio (%) in Lao PDR?
Make the answer very short. 6.29. In the year 1993, what is the difference between the Gross enrolment ratio (%) in Upper middle income and Gross enrolment ratio (%) in Saudi Arabia?
Your answer should be compact. -6.9. In the year 1993, what is the difference between the Gross enrolment ratio (%) in Ghana and Gross enrolment ratio (%) in Lao PDR?
Provide a short and direct response. -0.02. In the year 1993, what is the difference between the Gross enrolment ratio (%) in Ghana and Gross enrolment ratio (%) in Saudi Arabia?
Provide a short and direct response. -13.21. In the year 1993, what is the difference between the Gross enrolment ratio (%) in Lao PDR and Gross enrolment ratio (%) in Saudi Arabia?
Offer a very short reply. -13.19. In the year 1994, what is the difference between the Gross enrolment ratio (%) of Upper middle income and Gross enrolment ratio (%) of Ghana?
Your answer should be very brief. 7.04. In the year 1994, what is the difference between the Gross enrolment ratio (%) of Upper middle income and Gross enrolment ratio (%) of Lao PDR?
Make the answer very short. 7.04. In the year 1994, what is the difference between the Gross enrolment ratio (%) of Upper middle income and Gross enrolment ratio (%) of Saudi Arabia?
Give a very brief answer. -7.14. In the year 1994, what is the difference between the Gross enrolment ratio (%) of Ghana and Gross enrolment ratio (%) of Lao PDR?
Give a very brief answer. 0. In the year 1994, what is the difference between the Gross enrolment ratio (%) in Ghana and Gross enrolment ratio (%) in Saudi Arabia?
Give a very brief answer. -14.18. In the year 1994, what is the difference between the Gross enrolment ratio (%) of Lao PDR and Gross enrolment ratio (%) of Saudi Arabia?
Offer a very short reply. -14.18. In the year 2005, what is the difference between the Gross enrolment ratio (%) in Upper middle income and Gross enrolment ratio (%) in Ghana?
Make the answer very short. 16.86. In the year 2005, what is the difference between the Gross enrolment ratio (%) of Upper middle income and Gross enrolment ratio (%) of Lao PDR?
Your answer should be compact. 14.77. In the year 2005, what is the difference between the Gross enrolment ratio (%) in Upper middle income and Gross enrolment ratio (%) in Saudi Arabia?
Provide a succinct answer. -6.15. In the year 2005, what is the difference between the Gross enrolment ratio (%) of Ghana and Gross enrolment ratio (%) of Lao PDR?
Your answer should be very brief. -2.08. In the year 2005, what is the difference between the Gross enrolment ratio (%) of Ghana and Gross enrolment ratio (%) of Saudi Arabia?
Your answer should be compact. -23.01. In the year 2005, what is the difference between the Gross enrolment ratio (%) of Lao PDR and Gross enrolment ratio (%) of Saudi Arabia?
Give a very brief answer. -20.92. In the year 2006, what is the difference between the Gross enrolment ratio (%) in Upper middle income and Gross enrolment ratio (%) in Ghana?
Your answer should be compact. 18.86. In the year 2006, what is the difference between the Gross enrolment ratio (%) of Upper middle income and Gross enrolment ratio (%) of Lao PDR?
Your answer should be compact. 15.02. In the year 2006, what is the difference between the Gross enrolment ratio (%) in Upper middle income and Gross enrolment ratio (%) in Saudi Arabia?
Offer a very short reply. -5.71. In the year 2006, what is the difference between the Gross enrolment ratio (%) of Ghana and Gross enrolment ratio (%) of Lao PDR?
Offer a very short reply. -3.84. In the year 2006, what is the difference between the Gross enrolment ratio (%) in Ghana and Gross enrolment ratio (%) in Saudi Arabia?
Keep it short and to the point. -24.58. In the year 2006, what is the difference between the Gross enrolment ratio (%) of Lao PDR and Gross enrolment ratio (%) of Saudi Arabia?
Make the answer very short. -20.74. In the year 2007, what is the difference between the Gross enrolment ratio (%) in Upper middle income and Gross enrolment ratio (%) in Ghana?
Give a very brief answer. 18.52. In the year 2007, what is the difference between the Gross enrolment ratio (%) of Upper middle income and Gross enrolment ratio (%) of Lao PDR?
Ensure brevity in your answer.  13.48. In the year 2007, what is the difference between the Gross enrolment ratio (%) of Upper middle income and Gross enrolment ratio (%) of Saudi Arabia?
Keep it short and to the point. -4.78. In the year 2007, what is the difference between the Gross enrolment ratio (%) in Ghana and Gross enrolment ratio (%) in Lao PDR?
Your response must be concise. -5.05. In the year 2007, what is the difference between the Gross enrolment ratio (%) of Ghana and Gross enrolment ratio (%) of Saudi Arabia?
Offer a very short reply. -23.3. In the year 2007, what is the difference between the Gross enrolment ratio (%) of Lao PDR and Gross enrolment ratio (%) of Saudi Arabia?
Give a very brief answer. -18.25. What is the ratio of the Gross enrolment ratio (%) of Upper middle income in 1974 to that in 1975?
Ensure brevity in your answer.  0.87. What is the ratio of the Gross enrolment ratio (%) in Ghana in 1974 to that in 1975?
Provide a succinct answer. 0.95. What is the ratio of the Gross enrolment ratio (%) in Lao PDR in 1974 to that in 1975?
Your answer should be compact. 1.09. What is the ratio of the Gross enrolment ratio (%) of Saudi Arabia in 1974 to that in 1975?
Ensure brevity in your answer.  0.79. What is the ratio of the Gross enrolment ratio (%) of Upper middle income in 1974 to that in 1982?
Provide a short and direct response. 0.56. What is the ratio of the Gross enrolment ratio (%) in Ghana in 1974 to that in 1982?
Keep it short and to the point. 0.58. What is the ratio of the Gross enrolment ratio (%) in Lao PDR in 1974 to that in 1982?
Keep it short and to the point. 0.36. What is the ratio of the Gross enrolment ratio (%) of Saudi Arabia in 1974 to that in 1982?
Your response must be concise. 0.33. What is the ratio of the Gross enrolment ratio (%) in Upper middle income in 1974 to that in 1993?
Ensure brevity in your answer.  0.46. What is the ratio of the Gross enrolment ratio (%) of Ghana in 1974 to that in 1993?
Keep it short and to the point. 0.72. What is the ratio of the Gross enrolment ratio (%) in Lao PDR in 1974 to that in 1993?
Your answer should be compact. 0.24. What is the ratio of the Gross enrolment ratio (%) in Saudi Arabia in 1974 to that in 1993?
Provide a succinct answer. 0.17. What is the ratio of the Gross enrolment ratio (%) in Upper middle income in 1974 to that in 1994?
Provide a short and direct response. 0.42. What is the ratio of the Gross enrolment ratio (%) in Ghana in 1974 to that in 1994?
Your answer should be compact. 0.71. What is the ratio of the Gross enrolment ratio (%) in Lao PDR in 1974 to that in 1994?
Ensure brevity in your answer.  0.24. What is the ratio of the Gross enrolment ratio (%) in Saudi Arabia in 1974 to that in 1994?
Your answer should be very brief. 0.16. What is the ratio of the Gross enrolment ratio (%) of Upper middle income in 1974 to that in 2005?
Give a very brief answer. 0.16. What is the ratio of the Gross enrolment ratio (%) of Ghana in 1974 to that in 2005?
Your answer should be very brief. 0.16. What is the ratio of the Gross enrolment ratio (%) in Lao PDR in 1974 to that in 2005?
Your answer should be very brief. 0.04. What is the ratio of the Gross enrolment ratio (%) in Saudi Arabia in 1974 to that in 2005?
Give a very brief answer. 0.09. What is the ratio of the Gross enrolment ratio (%) of Upper middle income in 1974 to that in 2006?
Provide a succinct answer. 0.15. What is the ratio of the Gross enrolment ratio (%) of Ghana in 1974 to that in 2006?
Your answer should be very brief. 0.18. What is the ratio of the Gross enrolment ratio (%) in Lao PDR in 1974 to that in 2006?
Keep it short and to the point. 0.04. What is the ratio of the Gross enrolment ratio (%) of Saudi Arabia in 1974 to that in 2006?
Your response must be concise. 0.08. What is the ratio of the Gross enrolment ratio (%) in Upper middle income in 1974 to that in 2007?
Your answer should be very brief. 0.14. What is the ratio of the Gross enrolment ratio (%) of Ghana in 1974 to that in 2007?
Offer a terse response. 0.15. What is the ratio of the Gross enrolment ratio (%) of Lao PDR in 1974 to that in 2007?
Keep it short and to the point. 0.03. What is the ratio of the Gross enrolment ratio (%) of Saudi Arabia in 1974 to that in 2007?
Ensure brevity in your answer.  0.08. What is the ratio of the Gross enrolment ratio (%) in Upper middle income in 1975 to that in 1982?
Offer a terse response. 0.65. What is the ratio of the Gross enrolment ratio (%) in Ghana in 1975 to that in 1982?
Offer a very short reply. 0.62. What is the ratio of the Gross enrolment ratio (%) in Lao PDR in 1975 to that in 1982?
Your response must be concise. 0.33. What is the ratio of the Gross enrolment ratio (%) in Saudi Arabia in 1975 to that in 1982?
Provide a succinct answer. 0.41. What is the ratio of the Gross enrolment ratio (%) in Upper middle income in 1975 to that in 1993?
Offer a very short reply. 0.53. What is the ratio of the Gross enrolment ratio (%) of Ghana in 1975 to that in 1993?
Provide a short and direct response. 0.76. What is the ratio of the Gross enrolment ratio (%) of Lao PDR in 1975 to that in 1993?
Give a very brief answer. 0.22. What is the ratio of the Gross enrolment ratio (%) in Saudi Arabia in 1975 to that in 1993?
Your answer should be very brief. 0.22. What is the ratio of the Gross enrolment ratio (%) of Upper middle income in 1975 to that in 1994?
Provide a succinct answer. 0.48. What is the ratio of the Gross enrolment ratio (%) in Ghana in 1975 to that in 1994?
Provide a short and direct response. 0.75. What is the ratio of the Gross enrolment ratio (%) of Lao PDR in 1975 to that in 1994?
Provide a short and direct response. 0.23. What is the ratio of the Gross enrolment ratio (%) in Saudi Arabia in 1975 to that in 1994?
Make the answer very short. 0.2. What is the ratio of the Gross enrolment ratio (%) of Upper middle income in 1975 to that in 2005?
Your answer should be very brief. 0.18. What is the ratio of the Gross enrolment ratio (%) of Ghana in 1975 to that in 2005?
Your answer should be very brief. 0.17. What is the ratio of the Gross enrolment ratio (%) of Lao PDR in 1975 to that in 2005?
Keep it short and to the point. 0.04. What is the ratio of the Gross enrolment ratio (%) of Saudi Arabia in 1975 to that in 2005?
Your response must be concise. 0.11. What is the ratio of the Gross enrolment ratio (%) of Upper middle income in 1975 to that in 2006?
Your response must be concise. 0.17. What is the ratio of the Gross enrolment ratio (%) of Ghana in 1975 to that in 2006?
Ensure brevity in your answer.  0.19. What is the ratio of the Gross enrolment ratio (%) of Lao PDR in 1975 to that in 2006?
Provide a succinct answer. 0.03. What is the ratio of the Gross enrolment ratio (%) in Saudi Arabia in 1975 to that in 2006?
Provide a short and direct response. 0.11. What is the ratio of the Gross enrolment ratio (%) in Upper middle income in 1975 to that in 2007?
Ensure brevity in your answer.  0.16. What is the ratio of the Gross enrolment ratio (%) of Ghana in 1975 to that in 2007?
Offer a very short reply. 0.16. What is the ratio of the Gross enrolment ratio (%) in Lao PDR in 1975 to that in 2007?
Your answer should be very brief. 0.03. What is the ratio of the Gross enrolment ratio (%) of Saudi Arabia in 1975 to that in 2007?
Provide a short and direct response. 0.11. What is the ratio of the Gross enrolment ratio (%) of Upper middle income in 1982 to that in 1993?
Offer a very short reply. 0.81. What is the ratio of the Gross enrolment ratio (%) in Ghana in 1982 to that in 1993?
Provide a short and direct response. 1.23. What is the ratio of the Gross enrolment ratio (%) in Lao PDR in 1982 to that in 1993?
Offer a very short reply. 0.67. What is the ratio of the Gross enrolment ratio (%) in Saudi Arabia in 1982 to that in 1993?
Offer a terse response. 0.52. What is the ratio of the Gross enrolment ratio (%) of Upper middle income in 1982 to that in 1994?
Keep it short and to the point. 0.74. What is the ratio of the Gross enrolment ratio (%) in Ghana in 1982 to that in 1994?
Offer a very short reply. 1.21. What is the ratio of the Gross enrolment ratio (%) of Lao PDR in 1982 to that in 1994?
Provide a short and direct response. 0.68. What is the ratio of the Gross enrolment ratio (%) of Saudi Arabia in 1982 to that in 1994?
Provide a short and direct response. 0.49. What is the ratio of the Gross enrolment ratio (%) in Upper middle income in 1982 to that in 2005?
Offer a very short reply. 0.27. What is the ratio of the Gross enrolment ratio (%) of Ghana in 1982 to that in 2005?
Keep it short and to the point. 0.28. What is the ratio of the Gross enrolment ratio (%) of Lao PDR in 1982 to that in 2005?
Provide a short and direct response. 0.12. What is the ratio of the Gross enrolment ratio (%) in Saudi Arabia in 1982 to that in 2005?
Give a very brief answer. 0.26. What is the ratio of the Gross enrolment ratio (%) of Upper middle income in 1982 to that in 2006?
Your answer should be compact. 0.26. What is the ratio of the Gross enrolment ratio (%) of Ghana in 1982 to that in 2006?
Provide a succinct answer. 0.32. What is the ratio of the Gross enrolment ratio (%) in Lao PDR in 1982 to that in 2006?
Give a very brief answer. 0.1. What is the ratio of the Gross enrolment ratio (%) in Saudi Arabia in 1982 to that in 2006?
Give a very brief answer. 0.26. What is the ratio of the Gross enrolment ratio (%) of Upper middle income in 1982 to that in 2007?
Provide a succinct answer. 0.25. What is the ratio of the Gross enrolment ratio (%) in Ghana in 1982 to that in 2007?
Offer a terse response. 0.25. What is the ratio of the Gross enrolment ratio (%) in Lao PDR in 1982 to that in 2007?
Your answer should be compact. 0.08. What is the ratio of the Gross enrolment ratio (%) in Saudi Arabia in 1982 to that in 2007?
Provide a succinct answer. 0.26. What is the ratio of the Gross enrolment ratio (%) of Upper middle income in 1993 to that in 1994?
Keep it short and to the point. 0.91. What is the ratio of the Gross enrolment ratio (%) of Ghana in 1993 to that in 1994?
Your answer should be very brief. 0.99. What is the ratio of the Gross enrolment ratio (%) of Lao PDR in 1993 to that in 1994?
Offer a very short reply. 1.01. What is the ratio of the Gross enrolment ratio (%) of Saudi Arabia in 1993 to that in 1994?
Keep it short and to the point. 0.94. What is the ratio of the Gross enrolment ratio (%) of Upper middle income in 1993 to that in 2005?
Ensure brevity in your answer.  0.34. What is the ratio of the Gross enrolment ratio (%) in Ghana in 1993 to that in 2005?
Your answer should be very brief. 0.23. What is the ratio of the Gross enrolment ratio (%) in Lao PDR in 1993 to that in 2005?
Keep it short and to the point. 0.17. What is the ratio of the Gross enrolment ratio (%) in Saudi Arabia in 1993 to that in 2005?
Your answer should be compact. 0.51. What is the ratio of the Gross enrolment ratio (%) of Upper middle income in 1993 to that in 2006?
Your answer should be very brief. 0.32. What is the ratio of the Gross enrolment ratio (%) of Ghana in 1993 to that in 2006?
Keep it short and to the point. 0.26. What is the ratio of the Gross enrolment ratio (%) in Lao PDR in 1993 to that in 2006?
Ensure brevity in your answer.  0.15. What is the ratio of the Gross enrolment ratio (%) of Saudi Arabia in 1993 to that in 2006?
Keep it short and to the point. 0.49. What is the ratio of the Gross enrolment ratio (%) in Upper middle income in 1993 to that in 2007?
Make the answer very short. 0.31. What is the ratio of the Gross enrolment ratio (%) in Ghana in 1993 to that in 2007?
Provide a succinct answer. 0.21. What is the ratio of the Gross enrolment ratio (%) in Lao PDR in 1993 to that in 2007?
Offer a terse response. 0.12. What is the ratio of the Gross enrolment ratio (%) in Saudi Arabia in 1993 to that in 2007?
Your answer should be compact. 0.49. What is the ratio of the Gross enrolment ratio (%) of Upper middle income in 1994 to that in 2005?
Your answer should be very brief. 0.37. What is the ratio of the Gross enrolment ratio (%) of Ghana in 1994 to that in 2005?
Offer a very short reply. 0.23. What is the ratio of the Gross enrolment ratio (%) of Lao PDR in 1994 to that in 2005?
Offer a very short reply. 0.17. What is the ratio of the Gross enrolment ratio (%) in Saudi Arabia in 1994 to that in 2005?
Provide a succinct answer. 0.54. What is the ratio of the Gross enrolment ratio (%) of Upper middle income in 1994 to that in 2006?
Offer a terse response. 0.35. What is the ratio of the Gross enrolment ratio (%) of Ghana in 1994 to that in 2006?
Your answer should be compact. 0.26. What is the ratio of the Gross enrolment ratio (%) in Lao PDR in 1994 to that in 2006?
Provide a succinct answer. 0.15. What is the ratio of the Gross enrolment ratio (%) in Saudi Arabia in 1994 to that in 2006?
Your answer should be compact. 0.52. What is the ratio of the Gross enrolment ratio (%) of Upper middle income in 1994 to that in 2007?
Ensure brevity in your answer.  0.34. What is the ratio of the Gross enrolment ratio (%) of Ghana in 1994 to that in 2007?
Give a very brief answer. 0.21. What is the ratio of the Gross enrolment ratio (%) of Lao PDR in 1994 to that in 2007?
Keep it short and to the point. 0.12. What is the ratio of the Gross enrolment ratio (%) of Saudi Arabia in 1994 to that in 2007?
Provide a short and direct response. 0.52. What is the ratio of the Gross enrolment ratio (%) of Upper middle income in 2005 to that in 2006?
Make the answer very short. 0.94. What is the ratio of the Gross enrolment ratio (%) of Ghana in 2005 to that in 2006?
Give a very brief answer. 1.11. What is the ratio of the Gross enrolment ratio (%) in Lao PDR in 2005 to that in 2006?
Ensure brevity in your answer.  0.87. What is the ratio of the Gross enrolment ratio (%) in Saudi Arabia in 2005 to that in 2006?
Offer a terse response. 0.97. What is the ratio of the Gross enrolment ratio (%) in Upper middle income in 2005 to that in 2007?
Offer a very short reply. 0.91. What is the ratio of the Gross enrolment ratio (%) in Ghana in 2005 to that in 2007?
Make the answer very short. 0.9. What is the ratio of the Gross enrolment ratio (%) of Lao PDR in 2005 to that in 2007?
Your answer should be very brief. 0.68. What is the ratio of the Gross enrolment ratio (%) in Saudi Arabia in 2005 to that in 2007?
Keep it short and to the point. 0.97. What is the ratio of the Gross enrolment ratio (%) of Ghana in 2006 to that in 2007?
Keep it short and to the point. 0.81. What is the ratio of the Gross enrolment ratio (%) of Lao PDR in 2006 to that in 2007?
Give a very brief answer. 0.79. What is the ratio of the Gross enrolment ratio (%) in Saudi Arabia in 2006 to that in 2007?
Provide a succinct answer. 1. What is the difference between the highest and the second highest Gross enrolment ratio (%) of Upper middle income?
Give a very brief answer. 0.89. What is the difference between the highest and the second highest Gross enrolment ratio (%) in Ghana?
Your response must be concise. 0.64. What is the difference between the highest and the second highest Gross enrolment ratio (%) of Lao PDR?
Offer a very short reply. 2.43. What is the difference between the highest and the second highest Gross enrolment ratio (%) in Saudi Arabia?
Your response must be concise. 0.05. What is the difference between the highest and the lowest Gross enrolment ratio (%) of Upper middle income?
Offer a very short reply. 21.37. What is the difference between the highest and the lowest Gross enrolment ratio (%) of Ghana?
Ensure brevity in your answer.  5.41. What is the difference between the highest and the lowest Gross enrolment ratio (%) in Lao PDR?
Offer a terse response. 11.1. What is the difference between the highest and the lowest Gross enrolment ratio (%) of Saudi Arabia?
Provide a succinct answer. 27.22. 